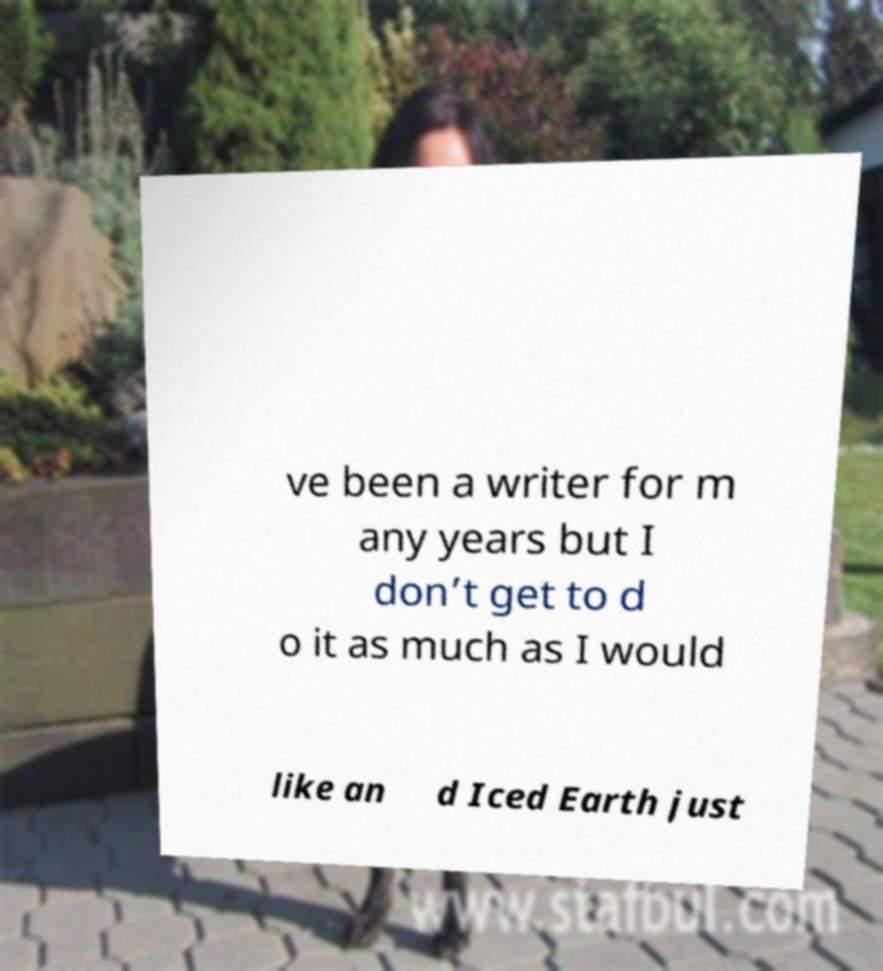Can you read and provide the text displayed in the image?This photo seems to have some interesting text. Can you extract and type it out for me? ve been a writer for m any years but I don’t get to d o it as much as I would like an d Iced Earth just 